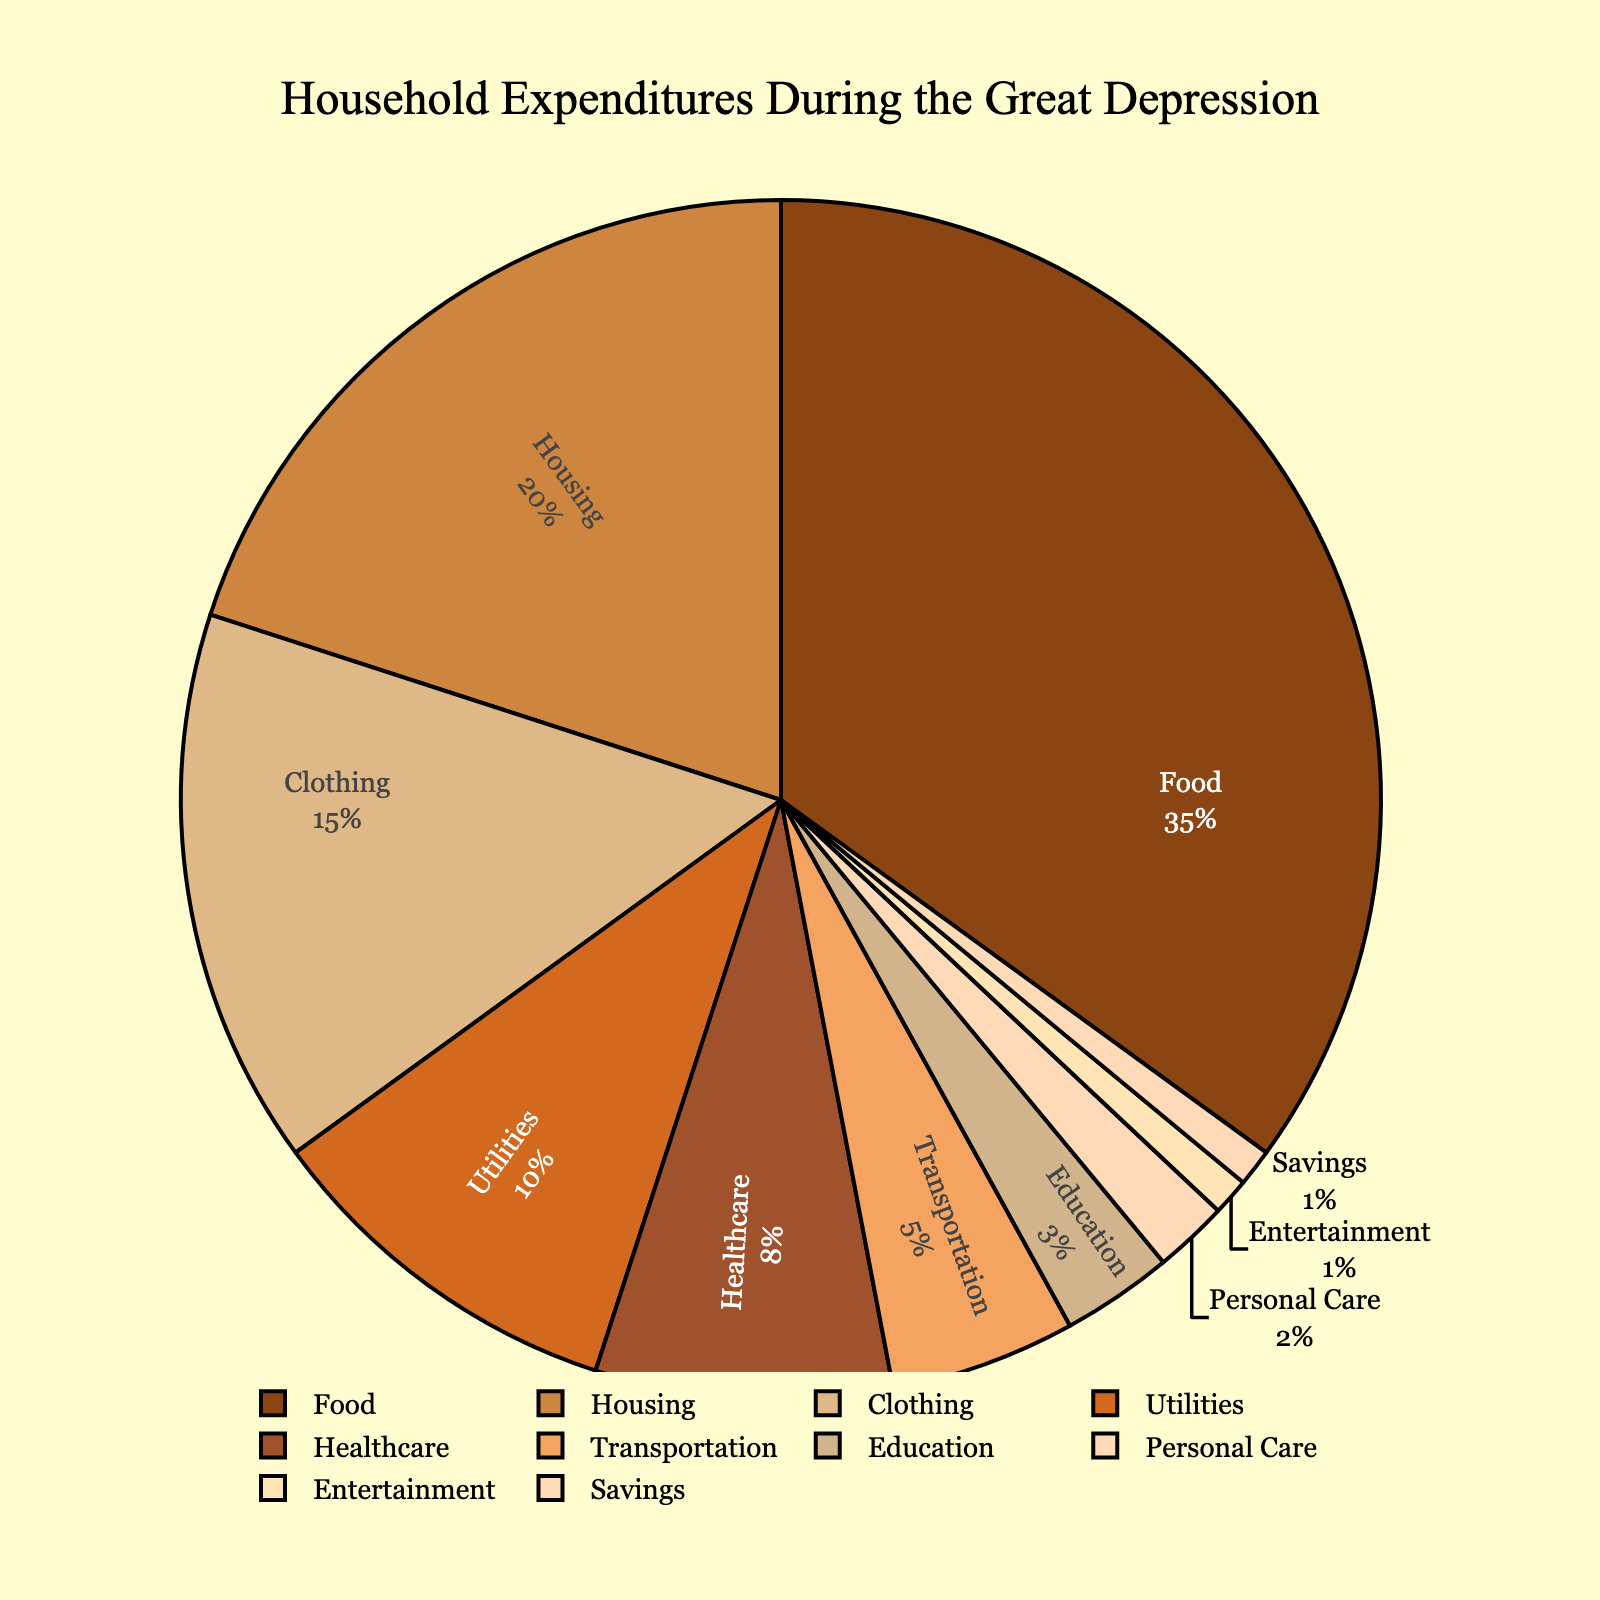What's the highest percentage category in household expenditures? The category with the highest percentage is the one with the largest value in the pie chart. By looking at the chart, we can see that Food has the highest percentage.
Answer: Food Which two categories combined have just over a third of the total expenditures? To find this, we need to identify two categories whose combined percentage is around 33%. Adding the percentages for Housing (20%) and Clothing (15%) gives us 35%, which is just over a third.
Answer: Housing and Clothing Which category has the smallest percentage of household expenditures? The category with the smallest percentage is the one with the smallest segment in the pie chart. From the chart, we can see that Savings contributes the least.
Answer: Savings By how much does the percentage for Food exceed the percentage for Healthcare? To determine this, subtract the percentage for Healthcare from the percentage for Food. Food is 35% and Healthcare is 8%, so 35% - 8% = 27%.
Answer: 27% What percentage of household expenditures is allocated to Utilities and Transportation combined? Add the percentages for Utilities and Transportation to find the combined allocation. Utilities is 10% and Transportation is 5%, so 10% + 5% = 15%.
Answer: 15% Which category has a higher percentage, Education or Personal Care? Compare the percentages of Education and Personal Care. Education is 3% while Personal Care is 2%, making Education higher.
Answer: Education Is the combined percentage of Housing, Utilities, and Transportation greater than that of Food? Calculate the sum of the percentages for Housing (20%), Utilities (10%), and Transportation (5%), which totals to 35%. Since Food is also 35%, they are equal.
Answer: No How does the percentage of Entertainment compare to that of Savings? Both Entertainment and Savings are mentioned to have a 1% expenditure each. This means they are equal.
Answer: They are equal What is the total percentage of household expenditures for non-essential categories like Entertainment, Personal Care, and Savings? Add the percentages for Entertainment (1%), Personal Care (2%), and Savings (1%). The total is 1% + 2% + 1% = 4%.
Answer: 4% By how much does the percentage for Clothing exceed that for Education? Subtract the percentage for Education from the percentage for Clothing. Clothing is 15% and Education is 3%, so 15% - 3% = 12%.
Answer: 12% 